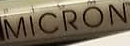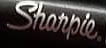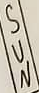What text appears in these images from left to right, separated by a semicolon? MICRON; Sharpie.; SUN 